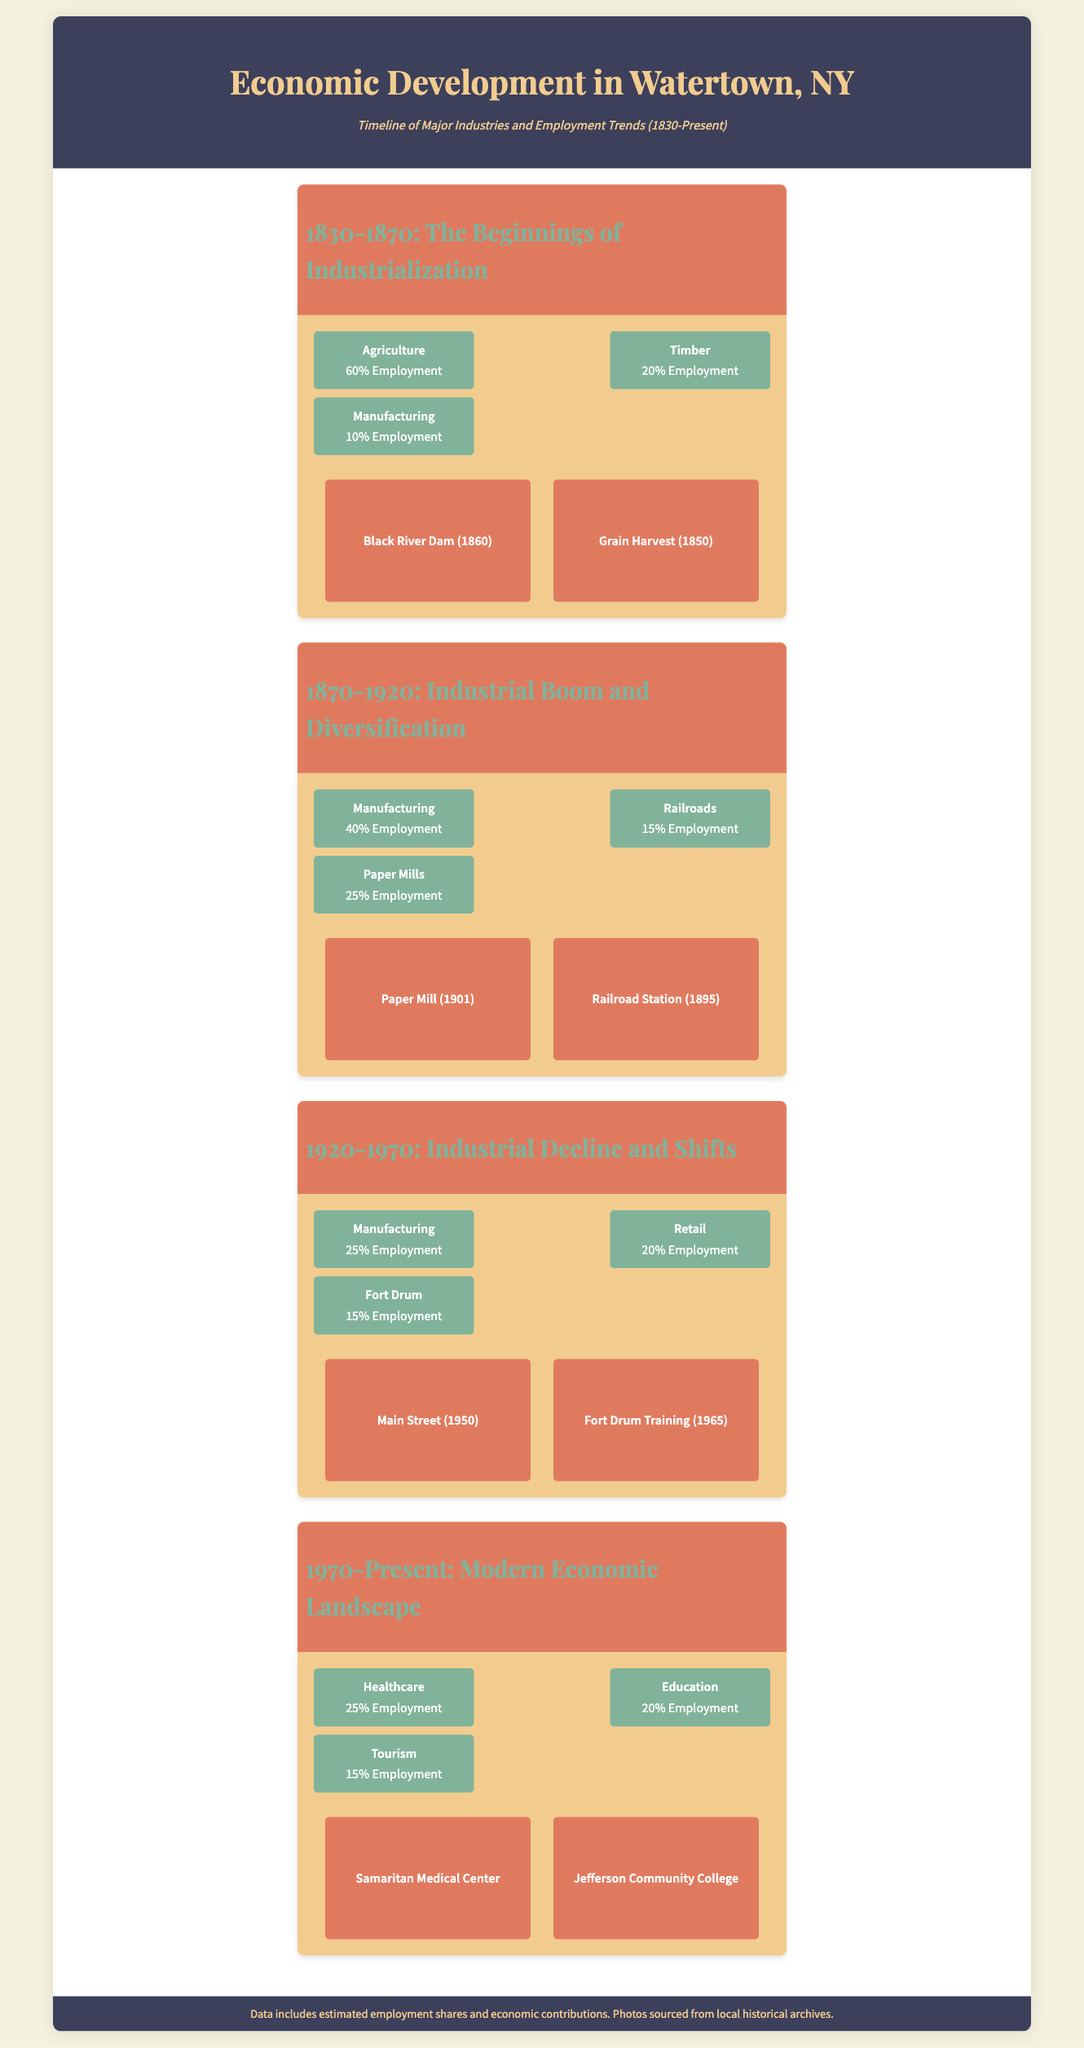what percentage of employment was in agriculture during 1830-1870? The document states that agriculture accounted for 60% of employment in the period 1830-1870.
Answer: 60% which industry had the highest employment percentage in 1870-1920? In the 1870-1920 period, manufacturing had the highest employment share at 40%.
Answer: Manufacturing what was the employment percentage for retail in 1920-1970? Retail employment during the 1920-1970 period was 20%.
Answer: 20% how many major industries are listed for the period 1970-Present? The document lists three major industries for the period 1970-Present.
Answer: Three which historic photo corresponds to the 1920-1970 period? The document indicates that "Main Street (1950)" and "Fort Drum Training (1965)" are photos from the 1920-1970 period.
Answer: Main Street (1950), Fort Drum Training (1965) what change occurred in the percentage of manufacturing employment from 1870-1920 to 1920-1970? Manufacturing employment decreased from 40% in 1870-1920 to 25% in 1920-1970.
Answer: Decrease what are the three industries with the highest employment in the period 1970-Present? The three industries with the highest employment in 1970-Present are Healthcare, Education, and Tourism.
Answer: Healthcare, Education, Tourism which decade marks the beginning of industrialization according to the timeline? The timeline indicates that industrialization began in the decade of the 1830s.
Answer: 1830s 